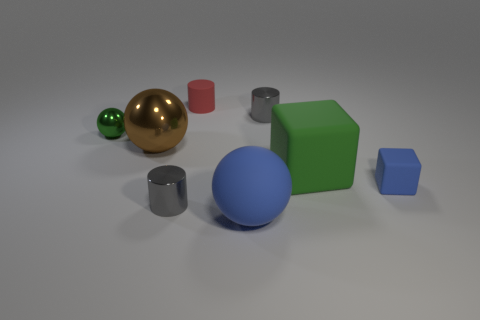Subtract all metallic balls. How many balls are left? 1 Subtract all purple balls. How many gray cylinders are left? 2 Add 1 big rubber objects. How many objects exist? 9 Subtract 1 cylinders. How many cylinders are left? 2 Subtract all cyan balls. Subtract all yellow cubes. How many balls are left? 3 Subtract all blocks. How many objects are left? 6 Add 4 brown spheres. How many brown spheres exist? 5 Subtract 0 yellow cubes. How many objects are left? 8 Subtract all green metallic balls. Subtract all tiny purple shiny things. How many objects are left? 7 Add 5 blue matte things. How many blue matte things are left? 7 